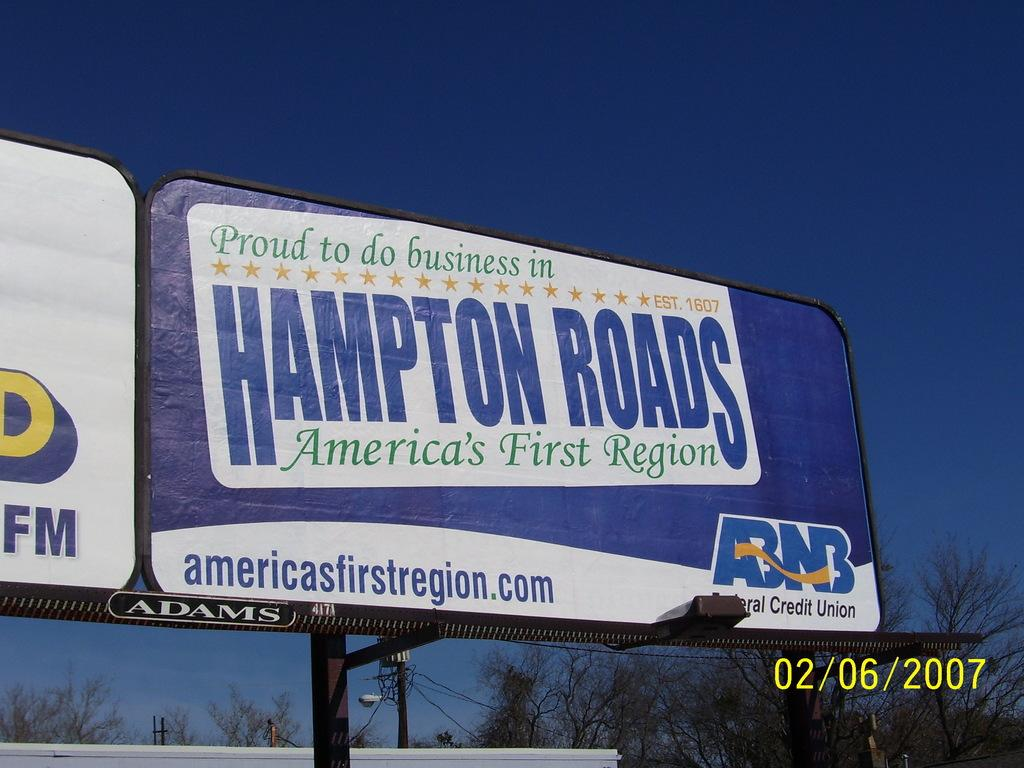<image>
Present a compact description of the photo's key features. Banner with proud to do business in Hampton Roads America's First Region. 